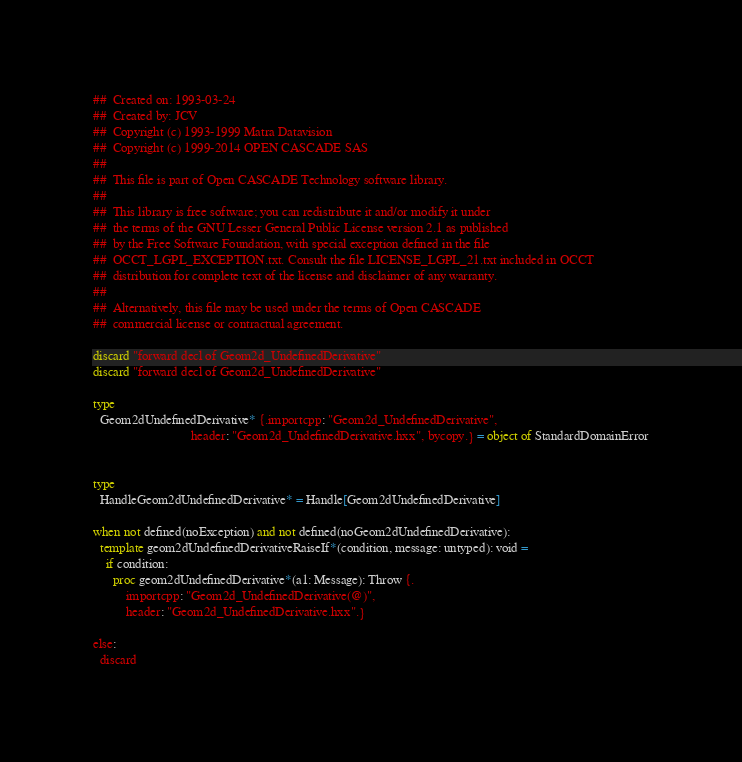Convert code to text. <code><loc_0><loc_0><loc_500><loc_500><_Nim_>##  Created on: 1993-03-24
##  Created by: JCV
##  Copyright (c) 1993-1999 Matra Datavision
##  Copyright (c) 1999-2014 OPEN CASCADE SAS
##
##  This file is part of Open CASCADE Technology software library.
##
##  This library is free software; you can redistribute it and/or modify it under
##  the terms of the GNU Lesser General Public License version 2.1 as published
##  by the Free Software Foundation, with special exception defined in the file
##  OCCT_LGPL_EXCEPTION.txt. Consult the file LICENSE_LGPL_21.txt included in OCCT
##  distribution for complete text of the license and disclaimer of any warranty.
##
##  Alternatively, this file may be used under the terms of Open CASCADE
##  commercial license or contractual agreement.

discard "forward decl of Geom2d_UndefinedDerivative"
discard "forward decl of Geom2d_UndefinedDerivative"

type
  Geom2dUndefinedDerivative* {.importcpp: "Geom2d_UndefinedDerivative",
                              header: "Geom2d_UndefinedDerivative.hxx", bycopy.} = object of StandardDomainError


type
  HandleGeom2dUndefinedDerivative* = Handle[Geom2dUndefinedDerivative]

when not defined(noException) and not defined(noGeom2dUndefinedDerivative):
  template geom2dUndefinedDerivativeRaiseIf*(condition, message: untyped): void =
    if condition:
      proc geom2dUndefinedDerivative*(a1: Message): Throw {.
          importcpp: "Geom2d_UndefinedDerivative(@)",
          header: "Geom2d_UndefinedDerivative.hxx".}

else:
  discard

</code> 